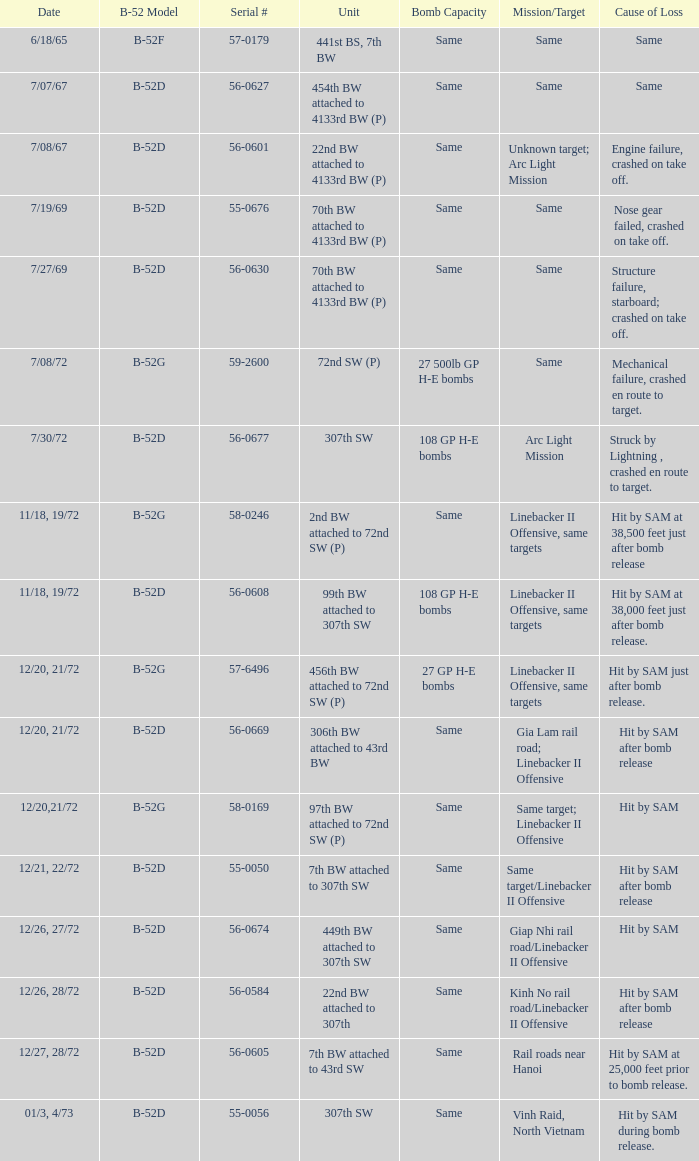When  27 gp h-e bombs the capacity of the bomb what is the cause of loss? Hit by SAM just after bomb release. 